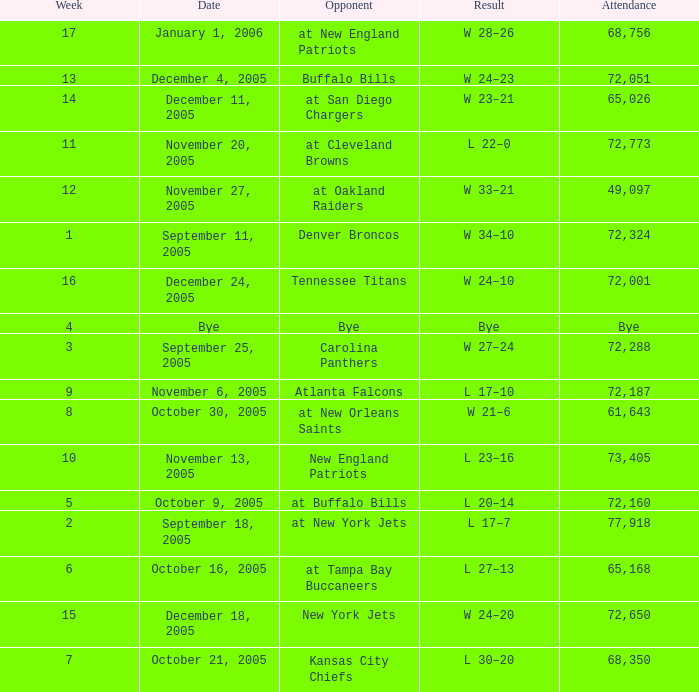In what Week was the Attendance 49,097? 12.0. 